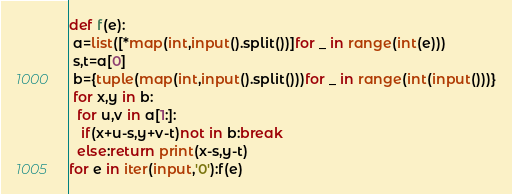<code> <loc_0><loc_0><loc_500><loc_500><_Python_>def f(e):
 a=list([*map(int,input().split())]for _ in range(int(e)))
 s,t=a[0]
 b={tuple(map(int,input().split()))for _ in range(int(input()))}
 for x,y in b:
  for u,v in a[1:]:
   if(x+u-s,y+v-t)not in b:break
  else:return print(x-s,y-t)
for e in iter(input,'0'):f(e)
</code> 